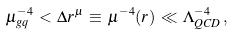Convert formula to latex. <formula><loc_0><loc_0><loc_500><loc_500>\mu _ { g q } ^ { - 4 } \, < \, \Delta r ^ { \mu } \, \equiv \, \mu ^ { - 4 } ( r ) \, \ll \, \Lambda _ { Q C D } ^ { - 4 } \, ,</formula> 